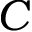Convert formula to latex. <formula><loc_0><loc_0><loc_500><loc_500>C</formula> 